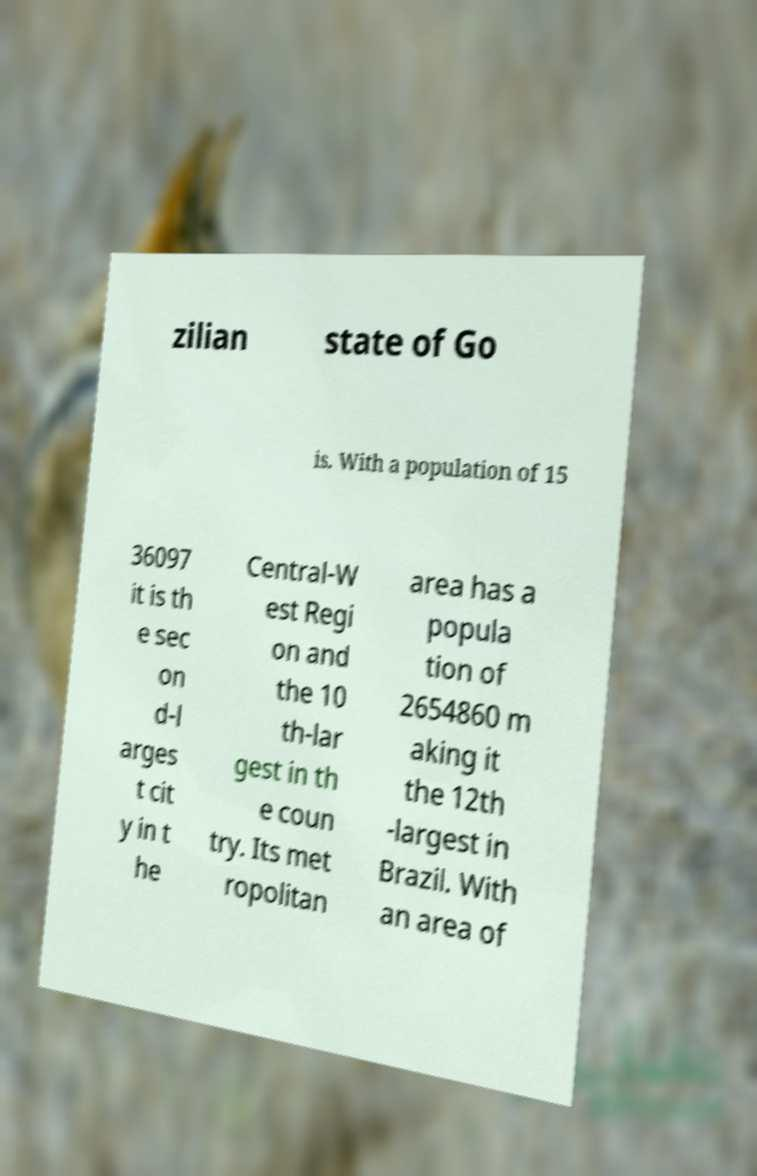I need the written content from this picture converted into text. Can you do that? zilian state of Go is. With a population of 15 36097 it is th e sec on d-l arges t cit y in t he Central-W est Regi on and the 10 th-lar gest in th e coun try. Its met ropolitan area has a popula tion of 2654860 m aking it the 12th -largest in Brazil. With an area of 